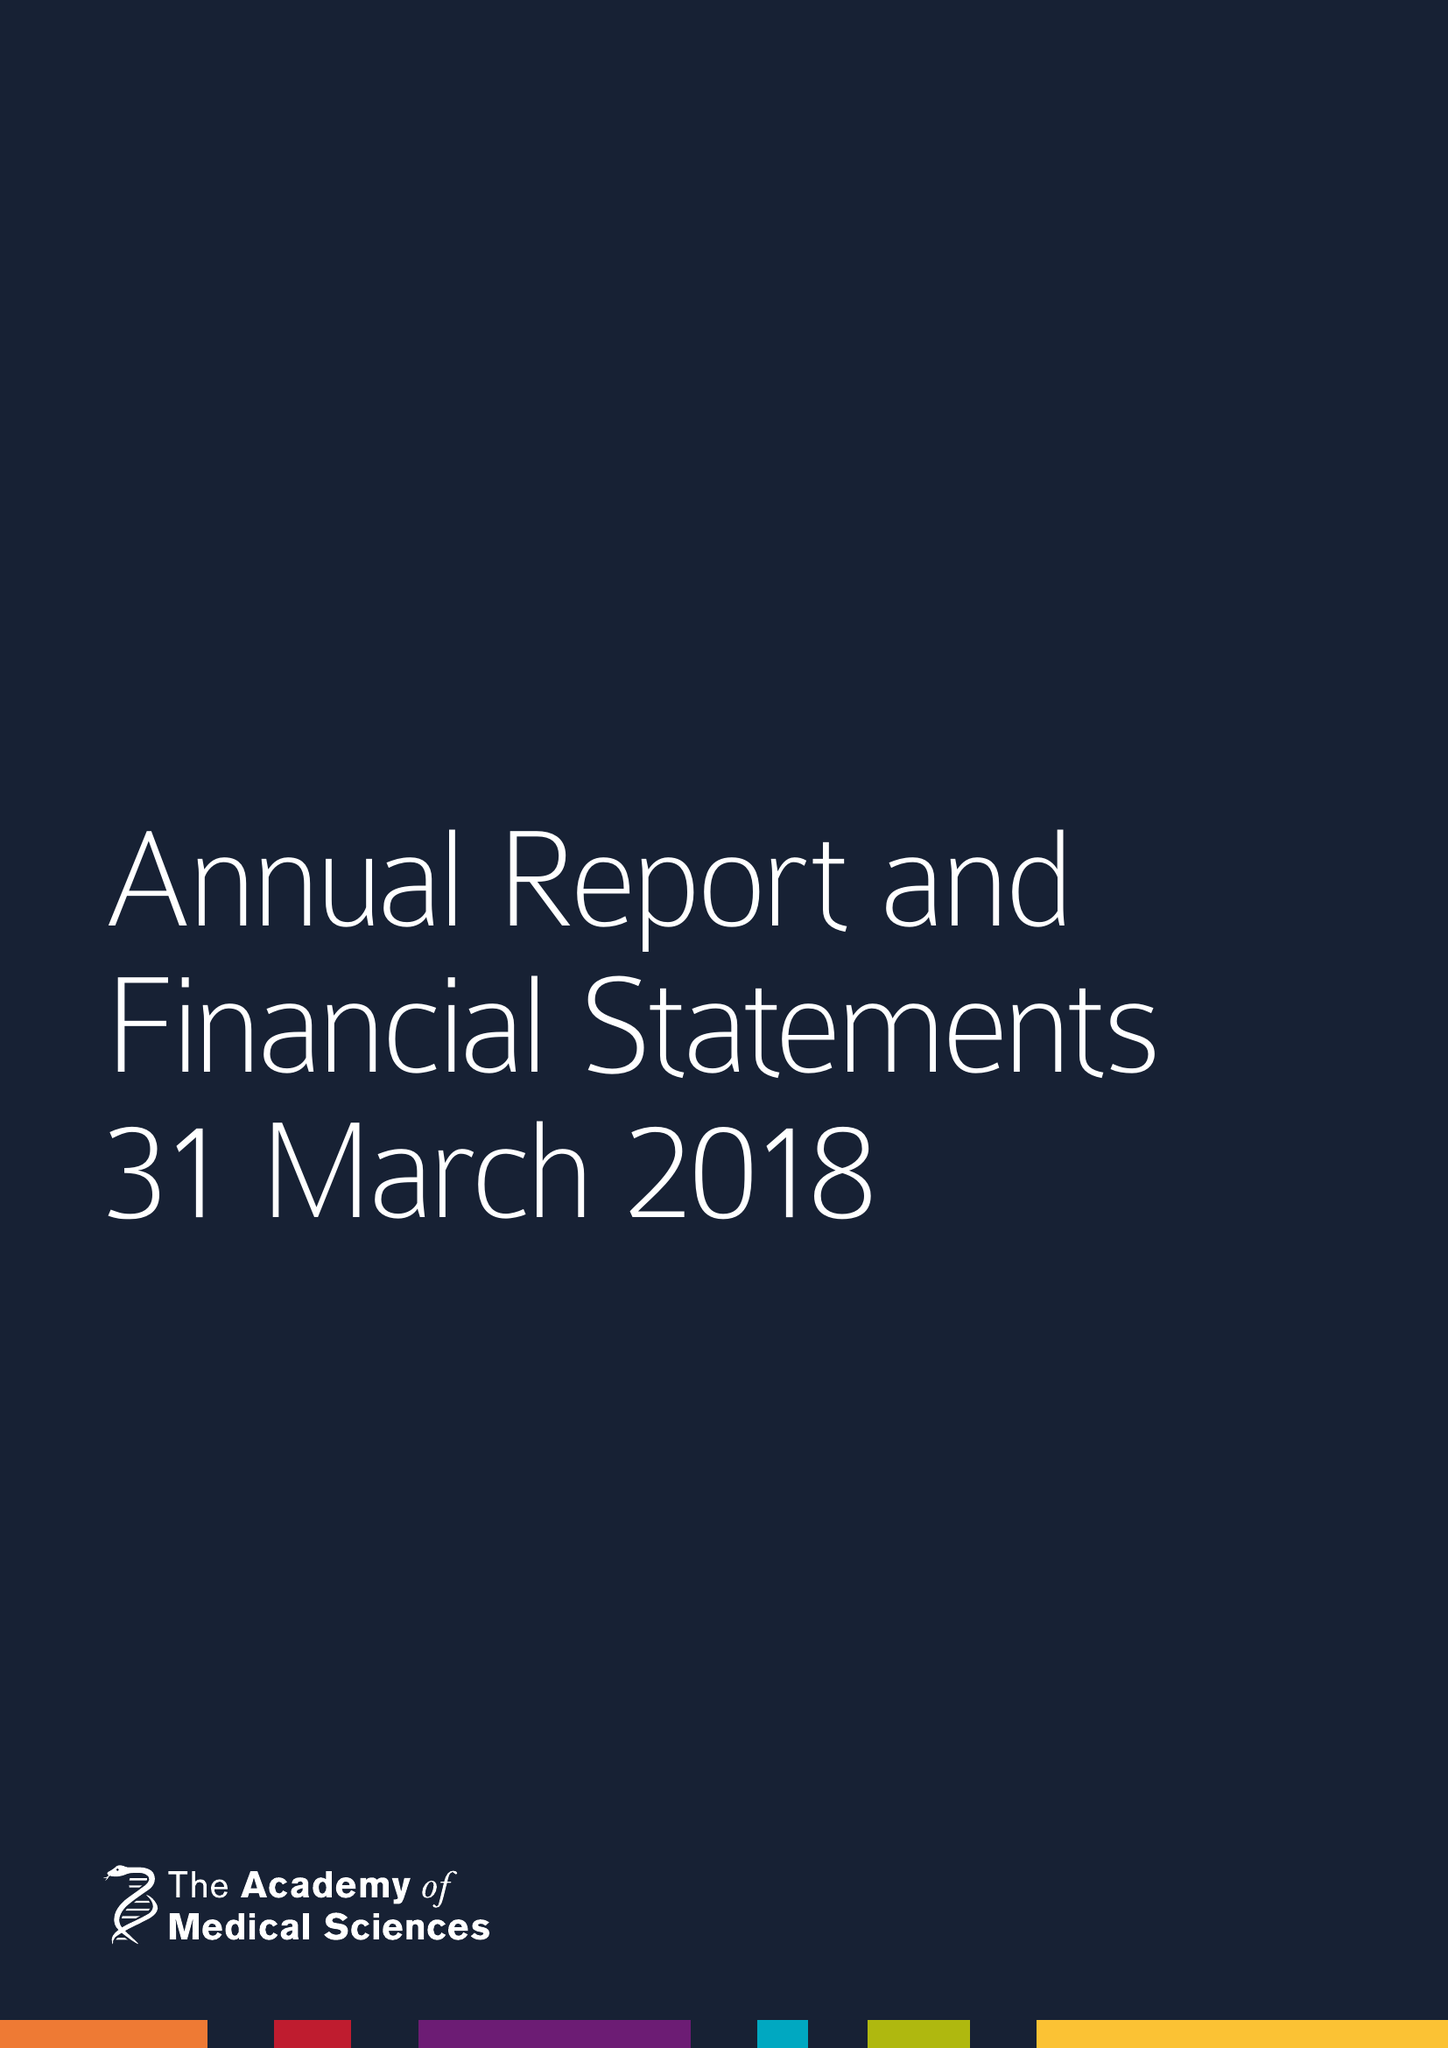What is the value for the address__postcode?
Answer the question using a single word or phrase. W1B 1QH 